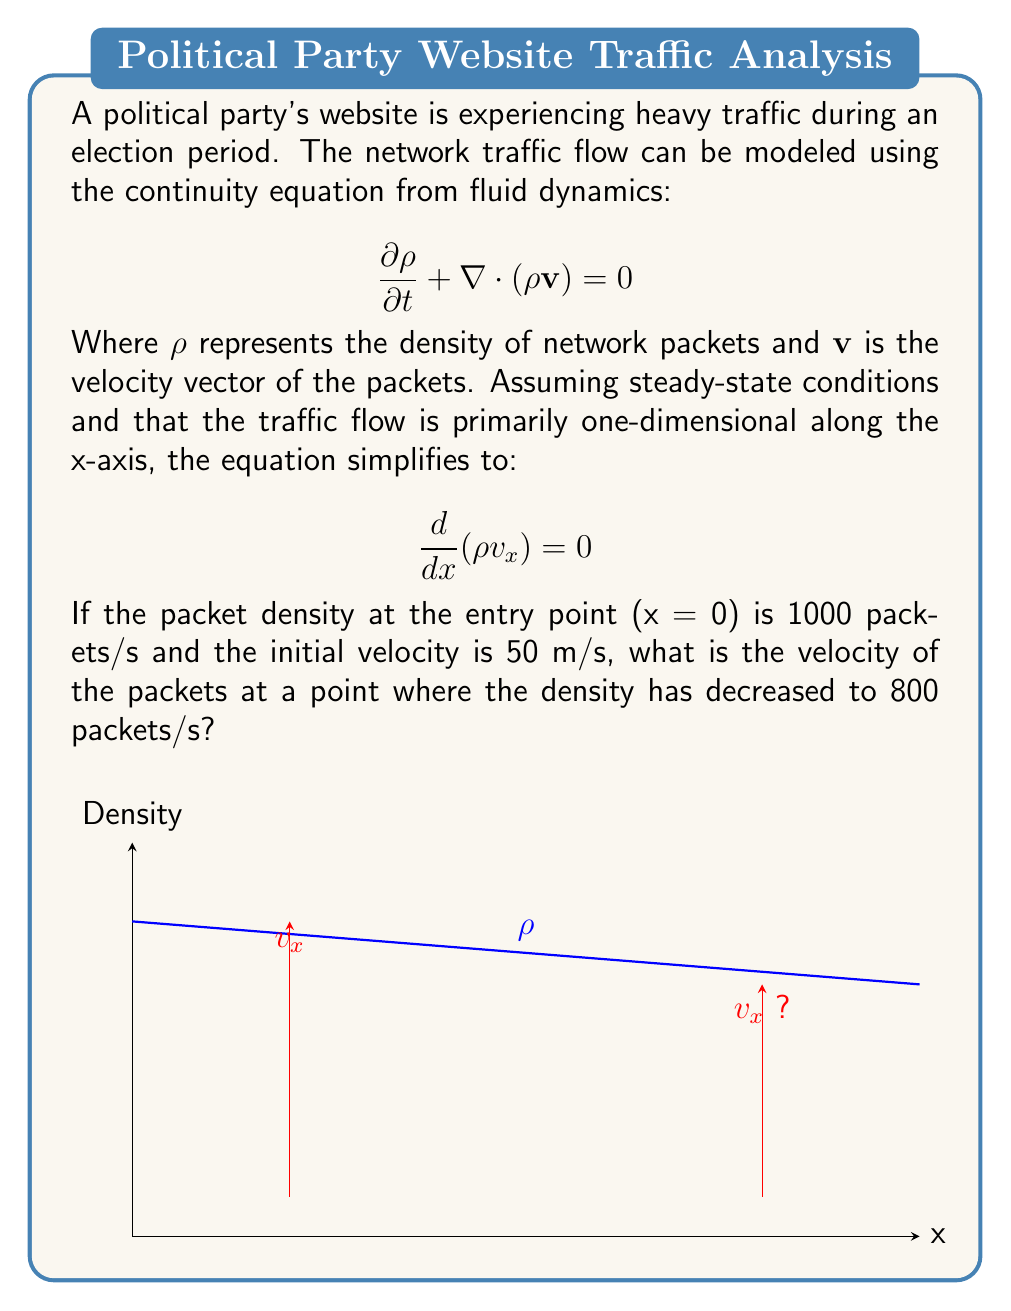Solve this math problem. Let's solve this step-by-step:

1) The simplified continuity equation is:
   $$\frac{d}{dx}(\rho v_x) = 0$$

2) This implies that $\rho v_x$ is constant along x. Let's call this constant $C$:
   $$\rho v_x = C$$

3) At the entry point (x = 0), we know:
   $\rho_0 = 1000$ packets/s
   $v_{x0} = 50$ m/s

4) We can calculate the constant $C$:
   $$C = \rho_0 v_{x0} = 1000 \cdot 50 = 50,000 \text{ packets} \cdot \text{m}/\text{s}^2$$

5) At the point of interest, we have:
   $\rho_1 = 800$ packets/s
   $v_{x1} = ?$ (this is what we need to find)

6) Using the constant $C$, we can write:
   $$\rho_1 v_{x1} = C = 50,000$$

7) Solving for $v_{x1}$:
   $$v_{x1} = \frac{50,000}{\rho_1} = \frac{50,000}{800} = 62.5 \text{ m/s}$$

Therefore, the velocity of the packets at the point where the density has decreased to 800 packets/s is 62.5 m/s.
Answer: 62.5 m/s 